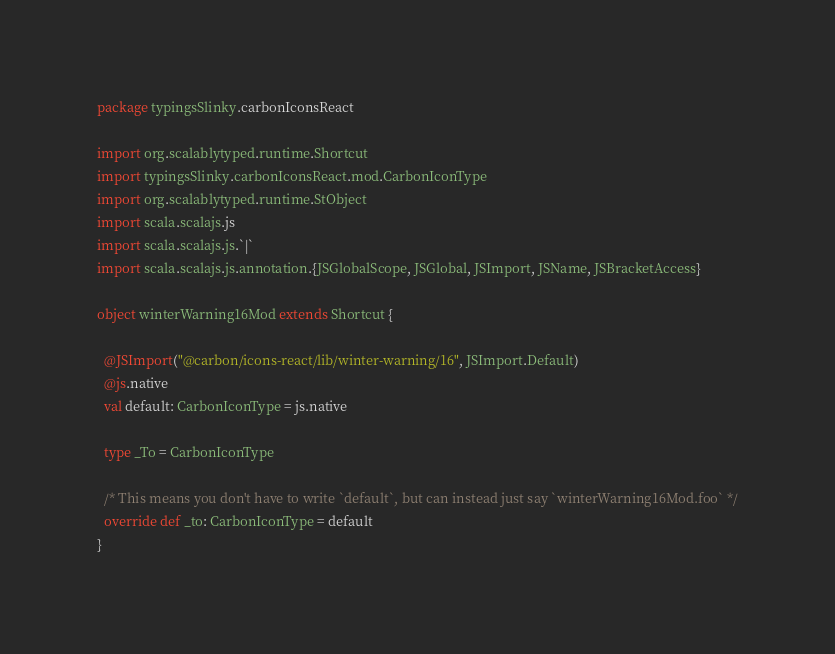<code> <loc_0><loc_0><loc_500><loc_500><_Scala_>package typingsSlinky.carbonIconsReact

import org.scalablytyped.runtime.Shortcut
import typingsSlinky.carbonIconsReact.mod.CarbonIconType
import org.scalablytyped.runtime.StObject
import scala.scalajs.js
import scala.scalajs.js.`|`
import scala.scalajs.js.annotation.{JSGlobalScope, JSGlobal, JSImport, JSName, JSBracketAccess}

object winterWarning16Mod extends Shortcut {
  
  @JSImport("@carbon/icons-react/lib/winter-warning/16", JSImport.Default)
  @js.native
  val default: CarbonIconType = js.native
  
  type _To = CarbonIconType
  
  /* This means you don't have to write `default`, but can instead just say `winterWarning16Mod.foo` */
  override def _to: CarbonIconType = default
}
</code> 